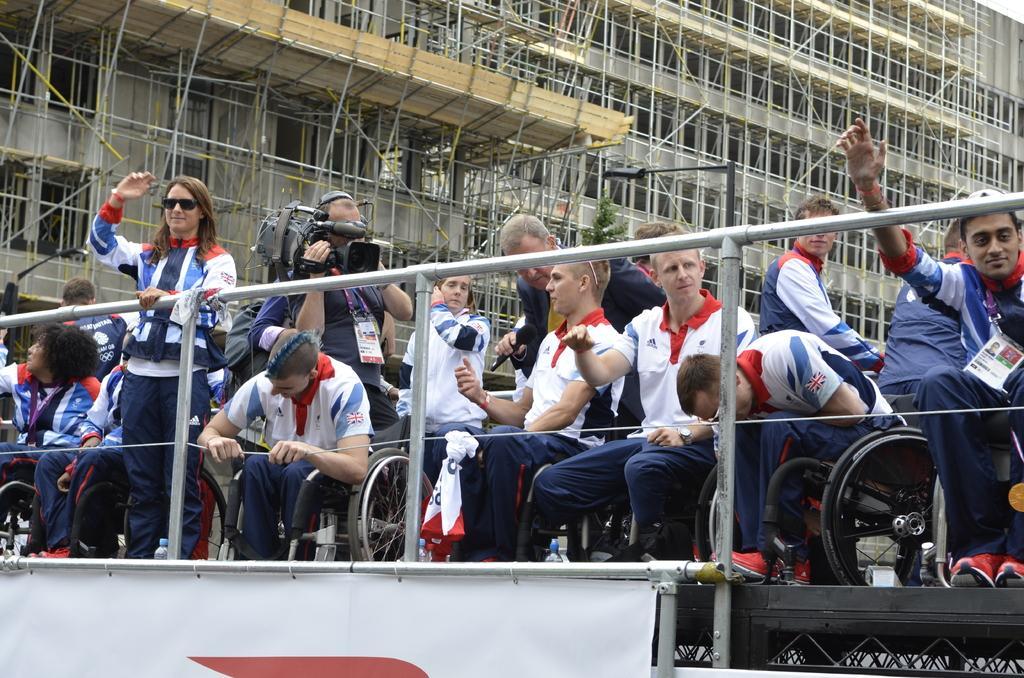In one or two sentences, can you explain what this image depicts? In the foreground of this image, there is a banner and railing. Behind it, there are people sitting on the wheel chairs. Few are standing and also a man holding a camera. In the background, there is a building under construction and the poles. 